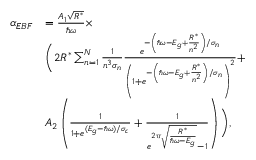Convert formula to latex. <formula><loc_0><loc_0><loc_500><loc_500>\begin{array} { r l } { \alpha _ { E B F } } & { = \frac { A _ { 1 } \sqrt { R ^ { * } } } { \hbar { \omega } } \times } \\ & { \left ( 2 R ^ { * } \sum _ { n = 1 } ^ { N } \frac { 1 } { n ^ { 3 } \sigma _ { n } } \frac { e ^ { - \left ( \hbar { \omega } - E _ { g } + \frac { R ^ { * } } { n ^ { 2 } } \right ) / \sigma _ { n } } } { \left ( 1 + e ^ { - \left ( \hbar { \omega } - E _ { g } + \frac { R ^ { * } } { n ^ { 2 } } \right ) / \sigma _ { n } } \right ) ^ { 2 } } + } \\ & { A _ { 2 } \left ( \frac { 1 } { 1 + e ^ { ( E _ { g } - \hbar { \omega } ) / \sigma _ { c } } } + \frac { 1 } { e ^ { 2 \pi \sqrt { \frac { R ^ { * } } { \hbar { \omega } - E _ { g } } } } - 1 } \right ) \right ) , } \end{array}</formula> 